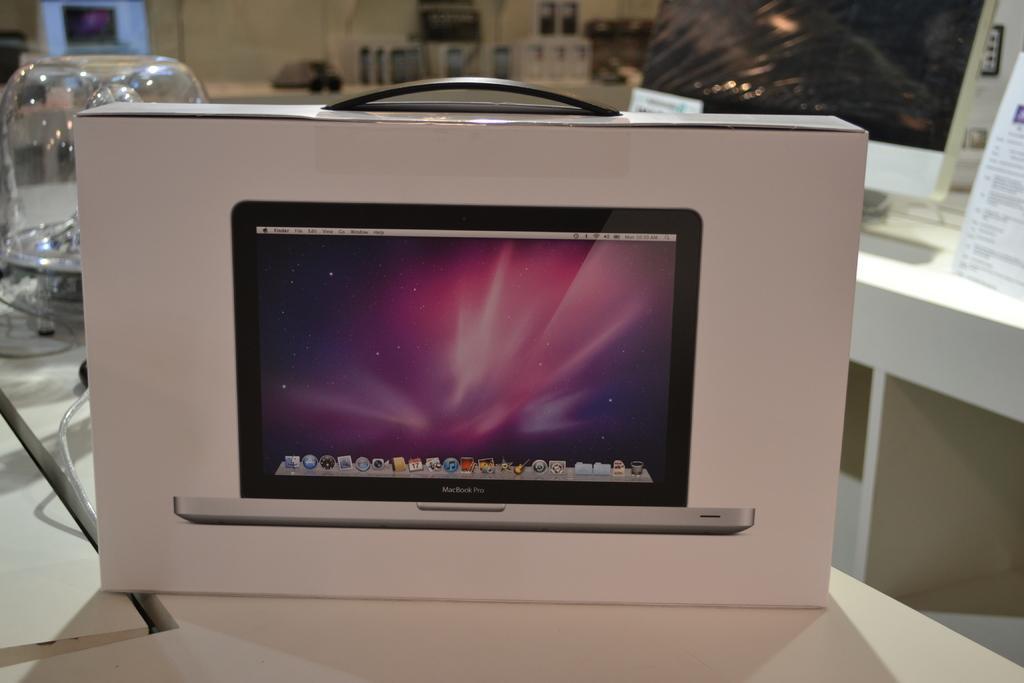Can you describe this image briefly? In this image there is a box having a laptop image on it. Box is kept on the table having a jar on it. Right side there is a table having posters on it. Top of image there is a table having few boxes which are having mobile images on it. 